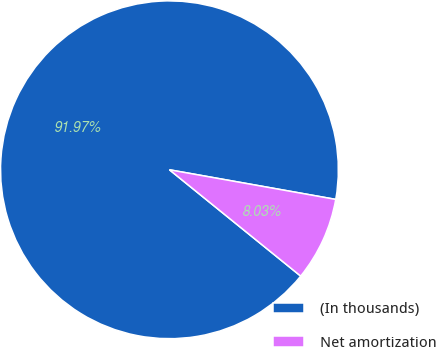<chart> <loc_0><loc_0><loc_500><loc_500><pie_chart><fcel>(In thousands)<fcel>Net amortization<nl><fcel>91.97%<fcel>8.03%<nl></chart> 